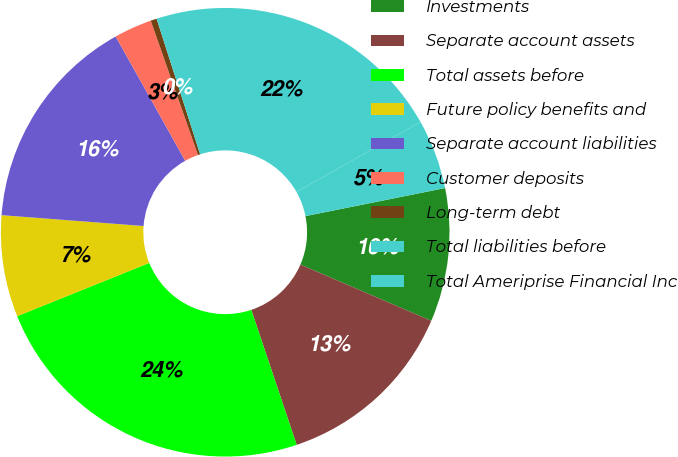Convert chart to OTSL. <chart><loc_0><loc_0><loc_500><loc_500><pie_chart><fcel>Investments<fcel>Separate account assets<fcel>Total assets before<fcel>Future policy benefits and<fcel>Separate account liabilities<fcel>Customer deposits<fcel>Long-term debt<fcel>Total liabilities before<fcel>Total Ameriprise Financial Inc<nl><fcel>9.62%<fcel>13.38%<fcel>24.06%<fcel>7.32%<fcel>15.67%<fcel>2.73%<fcel>0.44%<fcel>21.76%<fcel>5.03%<nl></chart> 